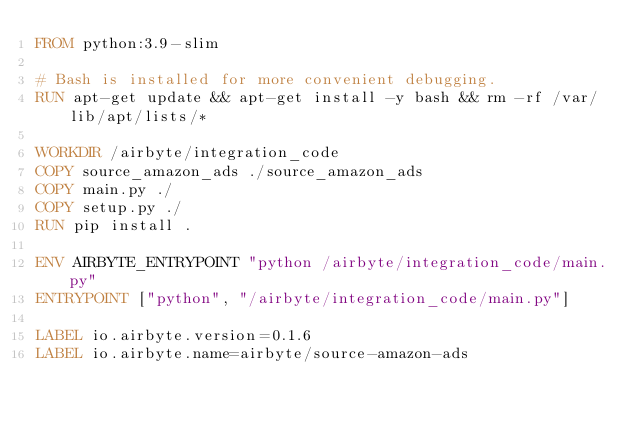Convert code to text. <code><loc_0><loc_0><loc_500><loc_500><_Dockerfile_>FROM python:3.9-slim

# Bash is installed for more convenient debugging.
RUN apt-get update && apt-get install -y bash && rm -rf /var/lib/apt/lists/*

WORKDIR /airbyte/integration_code
COPY source_amazon_ads ./source_amazon_ads
COPY main.py ./
COPY setup.py ./
RUN pip install .

ENV AIRBYTE_ENTRYPOINT "python /airbyte/integration_code/main.py"
ENTRYPOINT ["python", "/airbyte/integration_code/main.py"]

LABEL io.airbyte.version=0.1.6
LABEL io.airbyte.name=airbyte/source-amazon-ads
</code> 